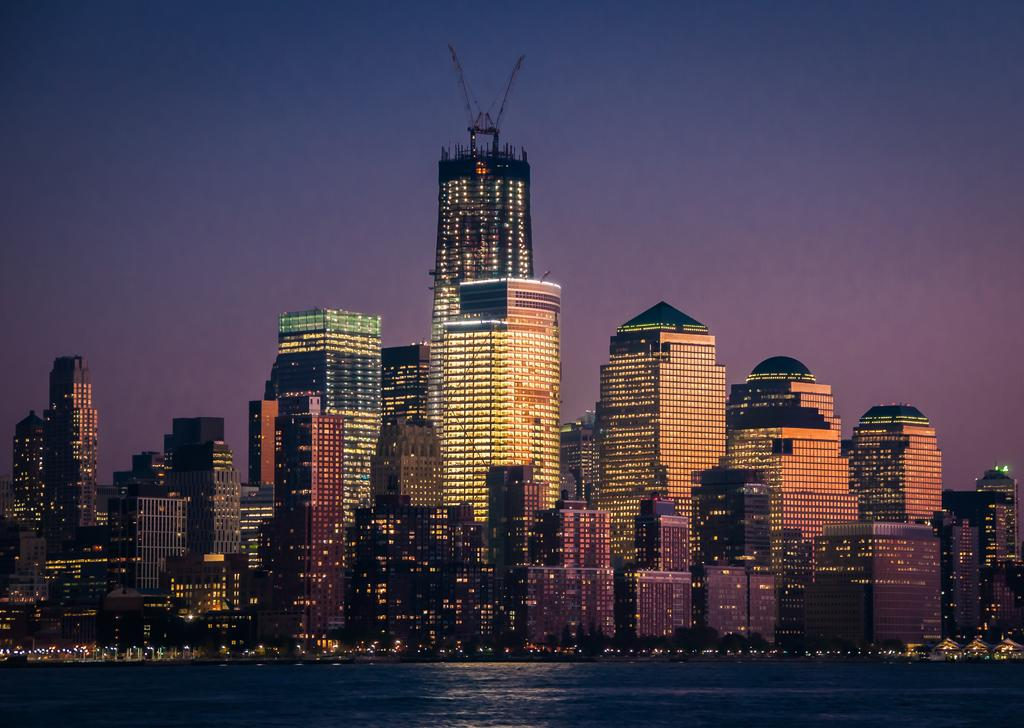What type of location is depicted in the image? The image is of a city. What can be seen in the foreground of the image? There is water in the foreground of the image. What are the main structures visible in the center of the image? There are buildings and skyscrapers in the center of the image. What is the source of illumination in the image? Lights are visible in the image. When was the image taken? The image was taken during night time. What type of sheet is being used to cover the crying baby in the image? There is no baby or sheet present in the image; it is a cityscape taken during night time. 